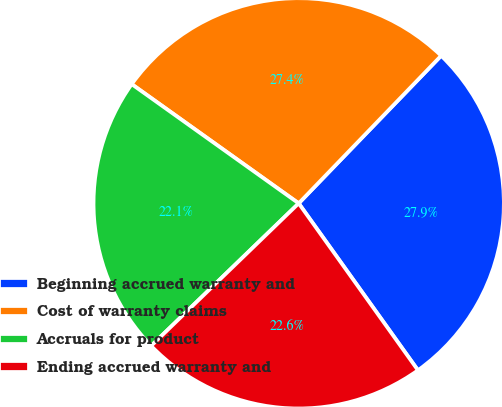Convert chart to OTSL. <chart><loc_0><loc_0><loc_500><loc_500><pie_chart><fcel>Beginning accrued warranty and<fcel>Cost of warranty claims<fcel>Accruals for product<fcel>Ending accrued warranty and<nl><fcel>27.91%<fcel>27.35%<fcel>22.09%<fcel>22.65%<nl></chart> 